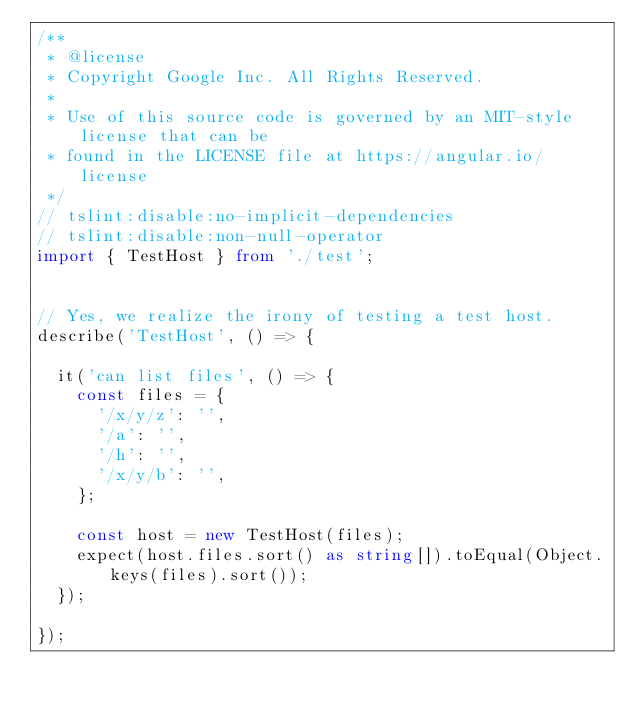<code> <loc_0><loc_0><loc_500><loc_500><_TypeScript_>/**
 * @license
 * Copyright Google Inc. All Rights Reserved.
 *
 * Use of this source code is governed by an MIT-style license that can be
 * found in the LICENSE file at https://angular.io/license
 */
// tslint:disable:no-implicit-dependencies
// tslint:disable:non-null-operator
import { TestHost } from './test';


// Yes, we realize the irony of testing a test host.
describe('TestHost', () => {

  it('can list files', () => {
    const files = {
      '/x/y/z': '',
      '/a': '',
      '/h': '',
      '/x/y/b': '',
    };

    const host = new TestHost(files);
    expect(host.files.sort() as string[]).toEqual(Object.keys(files).sort());
  });

});
</code> 